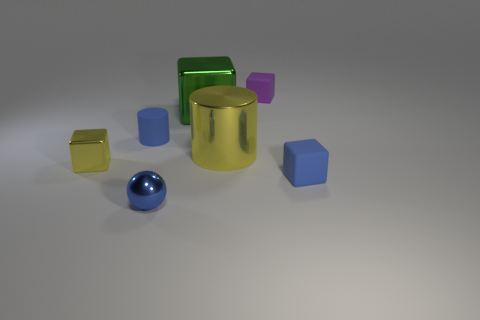Add 3 tiny blue metallic objects. How many objects exist? 10 Subtract all cylinders. How many objects are left? 5 Add 1 small metallic balls. How many small metallic balls are left? 2 Add 2 rubber cylinders. How many rubber cylinders exist? 3 Subtract 0 green balls. How many objects are left? 7 Subtract all small blue matte objects. Subtract all tiny blue things. How many objects are left? 2 